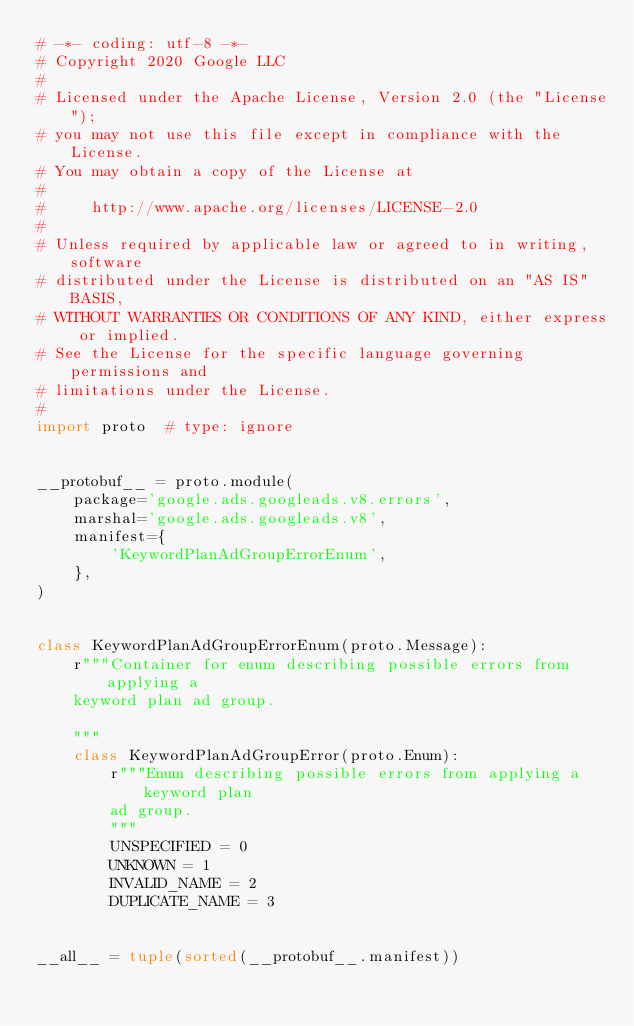Convert code to text. <code><loc_0><loc_0><loc_500><loc_500><_Python_># -*- coding: utf-8 -*-
# Copyright 2020 Google LLC
#
# Licensed under the Apache License, Version 2.0 (the "License");
# you may not use this file except in compliance with the License.
# You may obtain a copy of the License at
#
#     http://www.apache.org/licenses/LICENSE-2.0
#
# Unless required by applicable law or agreed to in writing, software
# distributed under the License is distributed on an "AS IS" BASIS,
# WITHOUT WARRANTIES OR CONDITIONS OF ANY KIND, either express or implied.
# See the License for the specific language governing permissions and
# limitations under the License.
#
import proto  # type: ignore


__protobuf__ = proto.module(
    package='google.ads.googleads.v8.errors',
    marshal='google.ads.googleads.v8',
    manifest={
        'KeywordPlanAdGroupErrorEnum',
    },
)


class KeywordPlanAdGroupErrorEnum(proto.Message):
    r"""Container for enum describing possible errors from applying a
    keyword plan ad group.

    """
    class KeywordPlanAdGroupError(proto.Enum):
        r"""Enum describing possible errors from applying a keyword plan
        ad group.
        """
        UNSPECIFIED = 0
        UNKNOWN = 1
        INVALID_NAME = 2
        DUPLICATE_NAME = 3


__all__ = tuple(sorted(__protobuf__.manifest))
</code> 